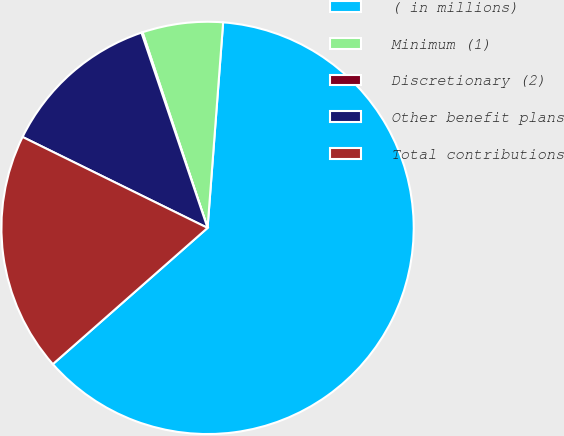Convert chart. <chart><loc_0><loc_0><loc_500><loc_500><pie_chart><fcel>( in millions)<fcel>Minimum (1)<fcel>Discretionary (2)<fcel>Other benefit plans<fcel>Total contributions<nl><fcel>62.3%<fcel>6.31%<fcel>0.09%<fcel>12.53%<fcel>18.76%<nl></chart> 